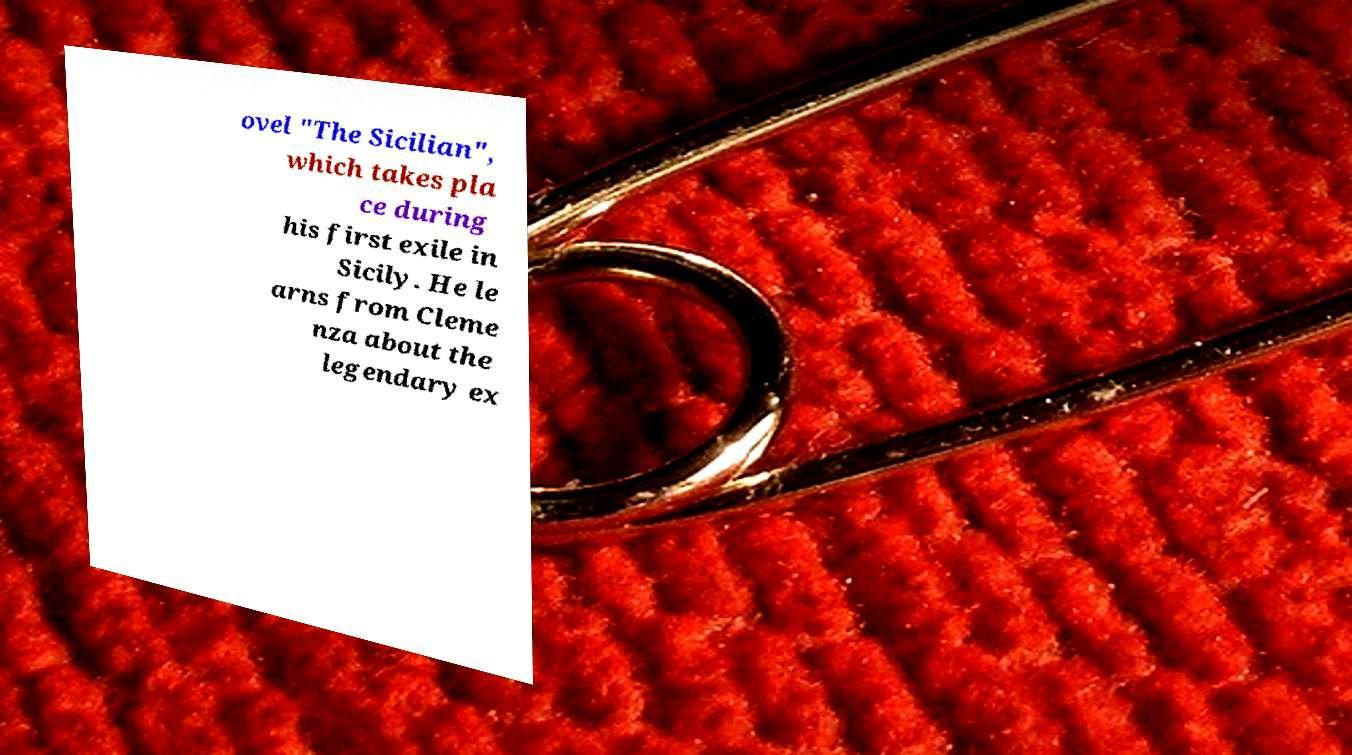Can you accurately transcribe the text from the provided image for me? ovel "The Sicilian", which takes pla ce during his first exile in Sicily. He le arns from Cleme nza about the legendary ex 